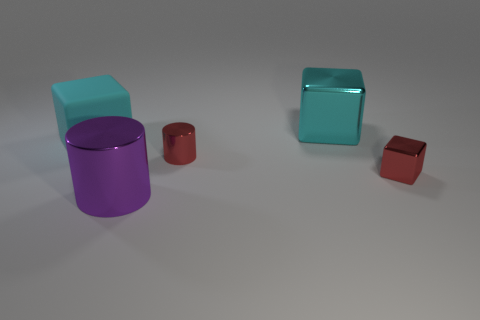Subtract all metallic blocks. How many blocks are left? 1 Subtract 1 cubes. How many cubes are left? 2 Subtract all red blocks. How many blocks are left? 2 Subtract all blocks. How many objects are left? 2 Add 2 tiny red shiny blocks. How many tiny red shiny blocks are left? 3 Add 5 purple metal cylinders. How many purple metal cylinders exist? 6 Add 2 big shiny objects. How many objects exist? 7 Subtract 0 gray cylinders. How many objects are left? 5 Subtract all red cubes. Subtract all red cylinders. How many cubes are left? 2 Subtract all brown blocks. How many purple cylinders are left? 1 